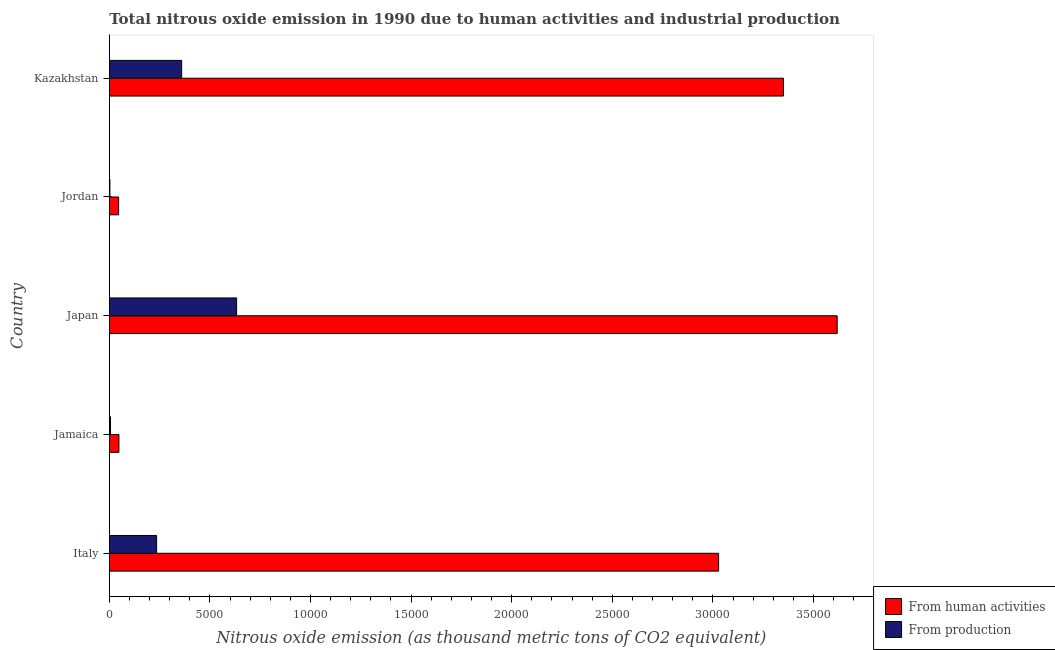How many bars are there on the 2nd tick from the bottom?
Give a very brief answer. 2. What is the label of the 5th group of bars from the top?
Offer a very short reply. Italy. What is the amount of emissions generated from industries in Jamaica?
Make the answer very short. 61.5. Across all countries, what is the maximum amount of emissions generated from industries?
Ensure brevity in your answer.  6328.4. Across all countries, what is the minimum amount of emissions from human activities?
Provide a succinct answer. 463.8. In which country was the amount of emissions generated from industries maximum?
Your answer should be very brief. Japan. In which country was the amount of emissions from human activities minimum?
Offer a terse response. Jordan. What is the total amount of emissions from human activities in the graph?
Your response must be concise. 1.01e+05. What is the difference between the amount of emissions generated from industries in Italy and that in Kazakhstan?
Your answer should be compact. -1245. What is the difference between the amount of emissions generated from industries in Japan and the amount of emissions from human activities in Jordan?
Make the answer very short. 5864.6. What is the average amount of emissions from human activities per country?
Give a very brief answer. 2.02e+04. What is the difference between the amount of emissions from human activities and amount of emissions generated from industries in Jamaica?
Your response must be concise. 417.7. In how many countries, is the amount of emissions from human activities greater than 8000 thousand metric tons?
Offer a terse response. 3. What is the ratio of the amount of emissions generated from industries in Jordan to that in Kazakhstan?
Your answer should be compact. 0.01. What is the difference between the highest and the second highest amount of emissions generated from industries?
Your answer should be very brief. 2730.7. What is the difference between the highest and the lowest amount of emissions generated from industries?
Provide a succinct answer. 6297.2. What does the 2nd bar from the top in Japan represents?
Your answer should be compact. From human activities. What does the 1st bar from the bottom in Jamaica represents?
Give a very brief answer. From human activities. How many countries are there in the graph?
Keep it short and to the point. 5. What is the difference between two consecutive major ticks on the X-axis?
Your response must be concise. 5000. Does the graph contain grids?
Provide a succinct answer. No. Where does the legend appear in the graph?
Your answer should be very brief. Bottom right. How are the legend labels stacked?
Provide a short and direct response. Vertical. What is the title of the graph?
Provide a short and direct response. Total nitrous oxide emission in 1990 due to human activities and industrial production. Does "Lowest 10% of population" appear as one of the legend labels in the graph?
Your answer should be compact. No. What is the label or title of the X-axis?
Give a very brief answer. Nitrous oxide emission (as thousand metric tons of CO2 equivalent). What is the Nitrous oxide emission (as thousand metric tons of CO2 equivalent) in From human activities in Italy?
Offer a very short reply. 3.03e+04. What is the Nitrous oxide emission (as thousand metric tons of CO2 equivalent) of From production in Italy?
Your answer should be very brief. 2352.7. What is the Nitrous oxide emission (as thousand metric tons of CO2 equivalent) of From human activities in Jamaica?
Provide a short and direct response. 479.2. What is the Nitrous oxide emission (as thousand metric tons of CO2 equivalent) of From production in Jamaica?
Give a very brief answer. 61.5. What is the Nitrous oxide emission (as thousand metric tons of CO2 equivalent) of From human activities in Japan?
Provide a short and direct response. 3.62e+04. What is the Nitrous oxide emission (as thousand metric tons of CO2 equivalent) of From production in Japan?
Your answer should be very brief. 6328.4. What is the Nitrous oxide emission (as thousand metric tons of CO2 equivalent) of From human activities in Jordan?
Provide a short and direct response. 463.8. What is the Nitrous oxide emission (as thousand metric tons of CO2 equivalent) in From production in Jordan?
Keep it short and to the point. 31.2. What is the Nitrous oxide emission (as thousand metric tons of CO2 equivalent) of From human activities in Kazakhstan?
Provide a succinct answer. 3.35e+04. What is the Nitrous oxide emission (as thousand metric tons of CO2 equivalent) of From production in Kazakhstan?
Provide a succinct answer. 3597.7. Across all countries, what is the maximum Nitrous oxide emission (as thousand metric tons of CO2 equivalent) in From human activities?
Your response must be concise. 3.62e+04. Across all countries, what is the maximum Nitrous oxide emission (as thousand metric tons of CO2 equivalent) of From production?
Your answer should be compact. 6328.4. Across all countries, what is the minimum Nitrous oxide emission (as thousand metric tons of CO2 equivalent) in From human activities?
Your answer should be compact. 463.8. Across all countries, what is the minimum Nitrous oxide emission (as thousand metric tons of CO2 equivalent) in From production?
Make the answer very short. 31.2. What is the total Nitrous oxide emission (as thousand metric tons of CO2 equivalent) in From human activities in the graph?
Offer a terse response. 1.01e+05. What is the total Nitrous oxide emission (as thousand metric tons of CO2 equivalent) of From production in the graph?
Provide a succinct answer. 1.24e+04. What is the difference between the Nitrous oxide emission (as thousand metric tons of CO2 equivalent) of From human activities in Italy and that in Jamaica?
Your answer should be compact. 2.98e+04. What is the difference between the Nitrous oxide emission (as thousand metric tons of CO2 equivalent) of From production in Italy and that in Jamaica?
Your response must be concise. 2291.2. What is the difference between the Nitrous oxide emission (as thousand metric tons of CO2 equivalent) in From human activities in Italy and that in Japan?
Offer a very short reply. -5892.4. What is the difference between the Nitrous oxide emission (as thousand metric tons of CO2 equivalent) in From production in Italy and that in Japan?
Your answer should be very brief. -3975.7. What is the difference between the Nitrous oxide emission (as thousand metric tons of CO2 equivalent) in From human activities in Italy and that in Jordan?
Keep it short and to the point. 2.98e+04. What is the difference between the Nitrous oxide emission (as thousand metric tons of CO2 equivalent) of From production in Italy and that in Jordan?
Provide a short and direct response. 2321.5. What is the difference between the Nitrous oxide emission (as thousand metric tons of CO2 equivalent) in From human activities in Italy and that in Kazakhstan?
Make the answer very short. -3222.8. What is the difference between the Nitrous oxide emission (as thousand metric tons of CO2 equivalent) in From production in Italy and that in Kazakhstan?
Keep it short and to the point. -1245. What is the difference between the Nitrous oxide emission (as thousand metric tons of CO2 equivalent) of From human activities in Jamaica and that in Japan?
Your answer should be very brief. -3.57e+04. What is the difference between the Nitrous oxide emission (as thousand metric tons of CO2 equivalent) in From production in Jamaica and that in Japan?
Your answer should be very brief. -6266.9. What is the difference between the Nitrous oxide emission (as thousand metric tons of CO2 equivalent) in From production in Jamaica and that in Jordan?
Your response must be concise. 30.3. What is the difference between the Nitrous oxide emission (as thousand metric tons of CO2 equivalent) in From human activities in Jamaica and that in Kazakhstan?
Provide a succinct answer. -3.30e+04. What is the difference between the Nitrous oxide emission (as thousand metric tons of CO2 equivalent) of From production in Jamaica and that in Kazakhstan?
Offer a very short reply. -3536.2. What is the difference between the Nitrous oxide emission (as thousand metric tons of CO2 equivalent) of From human activities in Japan and that in Jordan?
Provide a succinct answer. 3.57e+04. What is the difference between the Nitrous oxide emission (as thousand metric tons of CO2 equivalent) in From production in Japan and that in Jordan?
Offer a very short reply. 6297.2. What is the difference between the Nitrous oxide emission (as thousand metric tons of CO2 equivalent) in From human activities in Japan and that in Kazakhstan?
Your answer should be very brief. 2669.6. What is the difference between the Nitrous oxide emission (as thousand metric tons of CO2 equivalent) of From production in Japan and that in Kazakhstan?
Give a very brief answer. 2730.7. What is the difference between the Nitrous oxide emission (as thousand metric tons of CO2 equivalent) of From human activities in Jordan and that in Kazakhstan?
Provide a succinct answer. -3.30e+04. What is the difference between the Nitrous oxide emission (as thousand metric tons of CO2 equivalent) of From production in Jordan and that in Kazakhstan?
Your answer should be very brief. -3566.5. What is the difference between the Nitrous oxide emission (as thousand metric tons of CO2 equivalent) of From human activities in Italy and the Nitrous oxide emission (as thousand metric tons of CO2 equivalent) of From production in Jamaica?
Your answer should be compact. 3.02e+04. What is the difference between the Nitrous oxide emission (as thousand metric tons of CO2 equivalent) of From human activities in Italy and the Nitrous oxide emission (as thousand metric tons of CO2 equivalent) of From production in Japan?
Offer a terse response. 2.40e+04. What is the difference between the Nitrous oxide emission (as thousand metric tons of CO2 equivalent) of From human activities in Italy and the Nitrous oxide emission (as thousand metric tons of CO2 equivalent) of From production in Jordan?
Make the answer very short. 3.03e+04. What is the difference between the Nitrous oxide emission (as thousand metric tons of CO2 equivalent) of From human activities in Italy and the Nitrous oxide emission (as thousand metric tons of CO2 equivalent) of From production in Kazakhstan?
Offer a terse response. 2.67e+04. What is the difference between the Nitrous oxide emission (as thousand metric tons of CO2 equivalent) in From human activities in Jamaica and the Nitrous oxide emission (as thousand metric tons of CO2 equivalent) in From production in Japan?
Your answer should be compact. -5849.2. What is the difference between the Nitrous oxide emission (as thousand metric tons of CO2 equivalent) in From human activities in Jamaica and the Nitrous oxide emission (as thousand metric tons of CO2 equivalent) in From production in Jordan?
Your answer should be compact. 448. What is the difference between the Nitrous oxide emission (as thousand metric tons of CO2 equivalent) in From human activities in Jamaica and the Nitrous oxide emission (as thousand metric tons of CO2 equivalent) in From production in Kazakhstan?
Your answer should be very brief. -3118.5. What is the difference between the Nitrous oxide emission (as thousand metric tons of CO2 equivalent) of From human activities in Japan and the Nitrous oxide emission (as thousand metric tons of CO2 equivalent) of From production in Jordan?
Provide a short and direct response. 3.61e+04. What is the difference between the Nitrous oxide emission (as thousand metric tons of CO2 equivalent) of From human activities in Japan and the Nitrous oxide emission (as thousand metric tons of CO2 equivalent) of From production in Kazakhstan?
Offer a very short reply. 3.26e+04. What is the difference between the Nitrous oxide emission (as thousand metric tons of CO2 equivalent) in From human activities in Jordan and the Nitrous oxide emission (as thousand metric tons of CO2 equivalent) in From production in Kazakhstan?
Offer a very short reply. -3133.9. What is the average Nitrous oxide emission (as thousand metric tons of CO2 equivalent) in From human activities per country?
Provide a succinct answer. 2.02e+04. What is the average Nitrous oxide emission (as thousand metric tons of CO2 equivalent) in From production per country?
Keep it short and to the point. 2474.3. What is the difference between the Nitrous oxide emission (as thousand metric tons of CO2 equivalent) of From human activities and Nitrous oxide emission (as thousand metric tons of CO2 equivalent) of From production in Italy?
Offer a very short reply. 2.79e+04. What is the difference between the Nitrous oxide emission (as thousand metric tons of CO2 equivalent) of From human activities and Nitrous oxide emission (as thousand metric tons of CO2 equivalent) of From production in Jamaica?
Provide a succinct answer. 417.7. What is the difference between the Nitrous oxide emission (as thousand metric tons of CO2 equivalent) in From human activities and Nitrous oxide emission (as thousand metric tons of CO2 equivalent) in From production in Japan?
Your answer should be compact. 2.98e+04. What is the difference between the Nitrous oxide emission (as thousand metric tons of CO2 equivalent) in From human activities and Nitrous oxide emission (as thousand metric tons of CO2 equivalent) in From production in Jordan?
Keep it short and to the point. 432.6. What is the difference between the Nitrous oxide emission (as thousand metric tons of CO2 equivalent) in From human activities and Nitrous oxide emission (as thousand metric tons of CO2 equivalent) in From production in Kazakhstan?
Give a very brief answer. 2.99e+04. What is the ratio of the Nitrous oxide emission (as thousand metric tons of CO2 equivalent) of From human activities in Italy to that in Jamaica?
Provide a short and direct response. 63.19. What is the ratio of the Nitrous oxide emission (as thousand metric tons of CO2 equivalent) of From production in Italy to that in Jamaica?
Keep it short and to the point. 38.26. What is the ratio of the Nitrous oxide emission (as thousand metric tons of CO2 equivalent) in From human activities in Italy to that in Japan?
Ensure brevity in your answer.  0.84. What is the ratio of the Nitrous oxide emission (as thousand metric tons of CO2 equivalent) of From production in Italy to that in Japan?
Ensure brevity in your answer.  0.37. What is the ratio of the Nitrous oxide emission (as thousand metric tons of CO2 equivalent) of From human activities in Italy to that in Jordan?
Make the answer very short. 65.29. What is the ratio of the Nitrous oxide emission (as thousand metric tons of CO2 equivalent) of From production in Italy to that in Jordan?
Offer a terse response. 75.41. What is the ratio of the Nitrous oxide emission (as thousand metric tons of CO2 equivalent) of From human activities in Italy to that in Kazakhstan?
Your answer should be very brief. 0.9. What is the ratio of the Nitrous oxide emission (as thousand metric tons of CO2 equivalent) of From production in Italy to that in Kazakhstan?
Keep it short and to the point. 0.65. What is the ratio of the Nitrous oxide emission (as thousand metric tons of CO2 equivalent) of From human activities in Jamaica to that in Japan?
Keep it short and to the point. 0.01. What is the ratio of the Nitrous oxide emission (as thousand metric tons of CO2 equivalent) in From production in Jamaica to that in Japan?
Provide a succinct answer. 0.01. What is the ratio of the Nitrous oxide emission (as thousand metric tons of CO2 equivalent) of From human activities in Jamaica to that in Jordan?
Keep it short and to the point. 1.03. What is the ratio of the Nitrous oxide emission (as thousand metric tons of CO2 equivalent) of From production in Jamaica to that in Jordan?
Make the answer very short. 1.97. What is the ratio of the Nitrous oxide emission (as thousand metric tons of CO2 equivalent) in From human activities in Jamaica to that in Kazakhstan?
Your response must be concise. 0.01. What is the ratio of the Nitrous oxide emission (as thousand metric tons of CO2 equivalent) of From production in Jamaica to that in Kazakhstan?
Offer a very short reply. 0.02. What is the ratio of the Nitrous oxide emission (as thousand metric tons of CO2 equivalent) of From human activities in Japan to that in Jordan?
Your response must be concise. 78. What is the ratio of the Nitrous oxide emission (as thousand metric tons of CO2 equivalent) in From production in Japan to that in Jordan?
Offer a terse response. 202.83. What is the ratio of the Nitrous oxide emission (as thousand metric tons of CO2 equivalent) in From human activities in Japan to that in Kazakhstan?
Your answer should be compact. 1.08. What is the ratio of the Nitrous oxide emission (as thousand metric tons of CO2 equivalent) in From production in Japan to that in Kazakhstan?
Offer a terse response. 1.76. What is the ratio of the Nitrous oxide emission (as thousand metric tons of CO2 equivalent) of From human activities in Jordan to that in Kazakhstan?
Ensure brevity in your answer.  0.01. What is the ratio of the Nitrous oxide emission (as thousand metric tons of CO2 equivalent) of From production in Jordan to that in Kazakhstan?
Offer a very short reply. 0.01. What is the difference between the highest and the second highest Nitrous oxide emission (as thousand metric tons of CO2 equivalent) of From human activities?
Offer a terse response. 2669.6. What is the difference between the highest and the second highest Nitrous oxide emission (as thousand metric tons of CO2 equivalent) of From production?
Ensure brevity in your answer.  2730.7. What is the difference between the highest and the lowest Nitrous oxide emission (as thousand metric tons of CO2 equivalent) of From human activities?
Offer a very short reply. 3.57e+04. What is the difference between the highest and the lowest Nitrous oxide emission (as thousand metric tons of CO2 equivalent) of From production?
Offer a very short reply. 6297.2. 